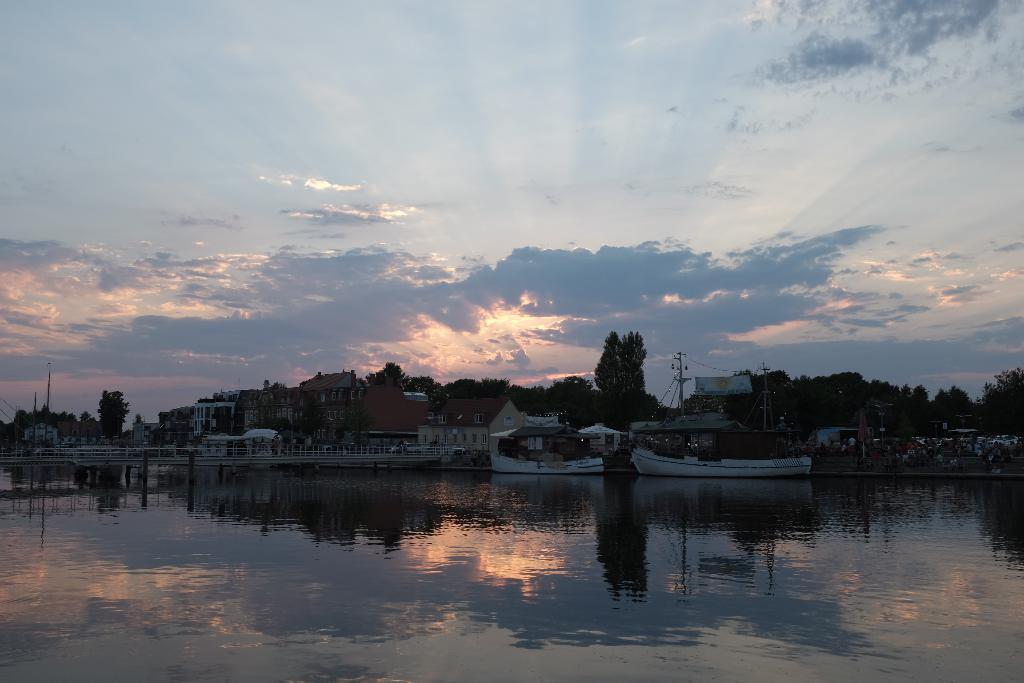What is on the water in the image? There are boats on the water in the image. What can be seen in the background of the image? There are trees and buildings in the background. What is the color of the sky in the image? The sky in the image is blue with clouds. Can you touch the bread in the image? There is no bread present in the image, so it cannot be touched. 